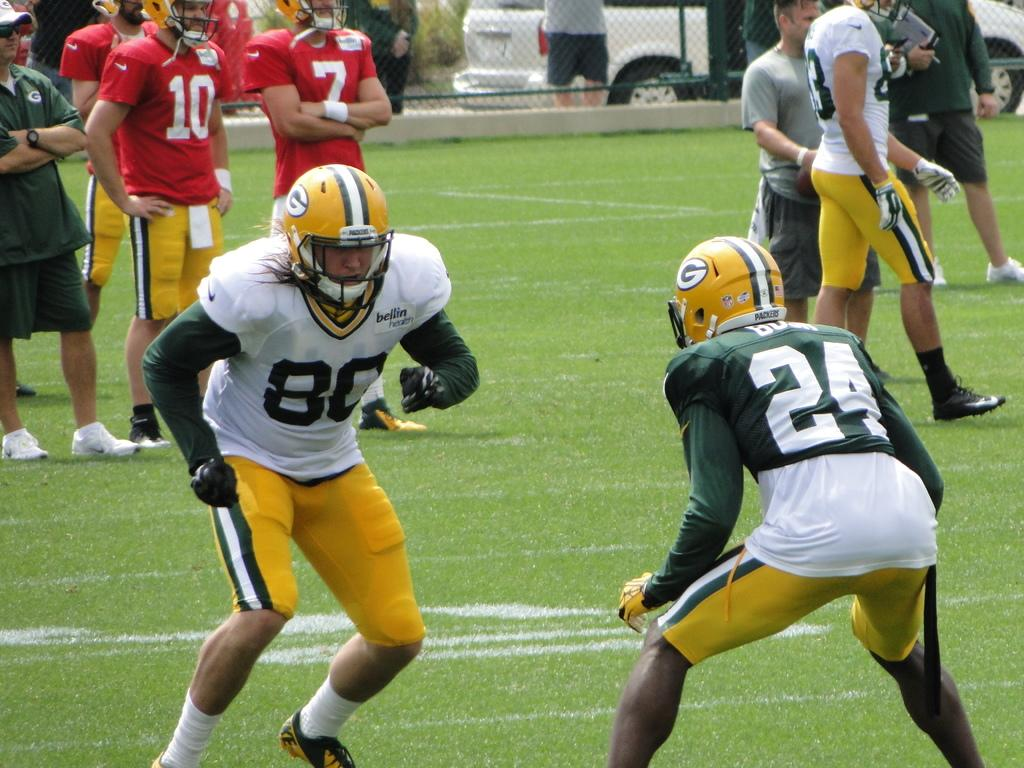Who or what is present in the image? There are people in the image. What are the people wearing? The people are wearing helmets. What type of terrain is visible in the image? There is grass in the image. What kind of barrier is present in the image? There is a fence in the image. What type of vehicle can be seen in the image? There is a white color car in the image. What other living organisms are present in the image? There are plants in the image. What store can be seen in the background of the image? There is no store visible in the image. What effect does the presence of the people have on the plants in the image? The presence of the people does not have any effect on the plants in the image, as they are separate entities. 